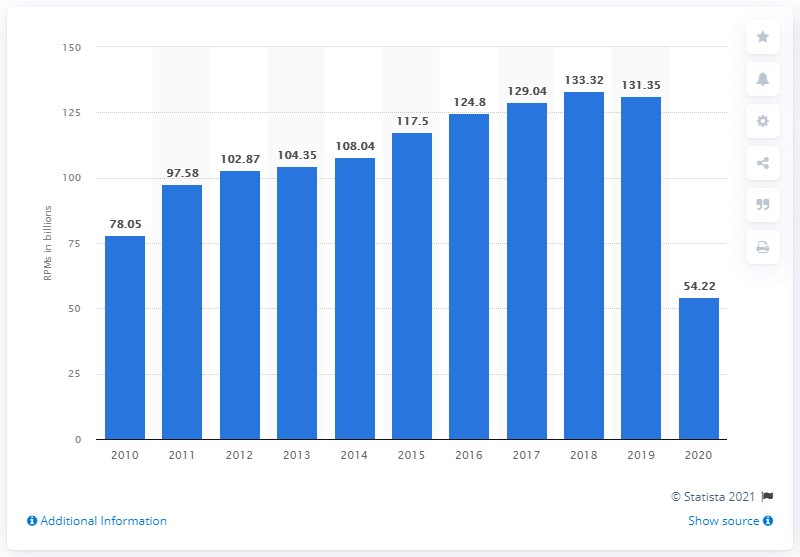Highlight a few significant elements in this photo. In 2020, Southwest Airlines traveled 54.22 miles. Southwest Airlines traveled a total of 131.35 miles in the prior year. 